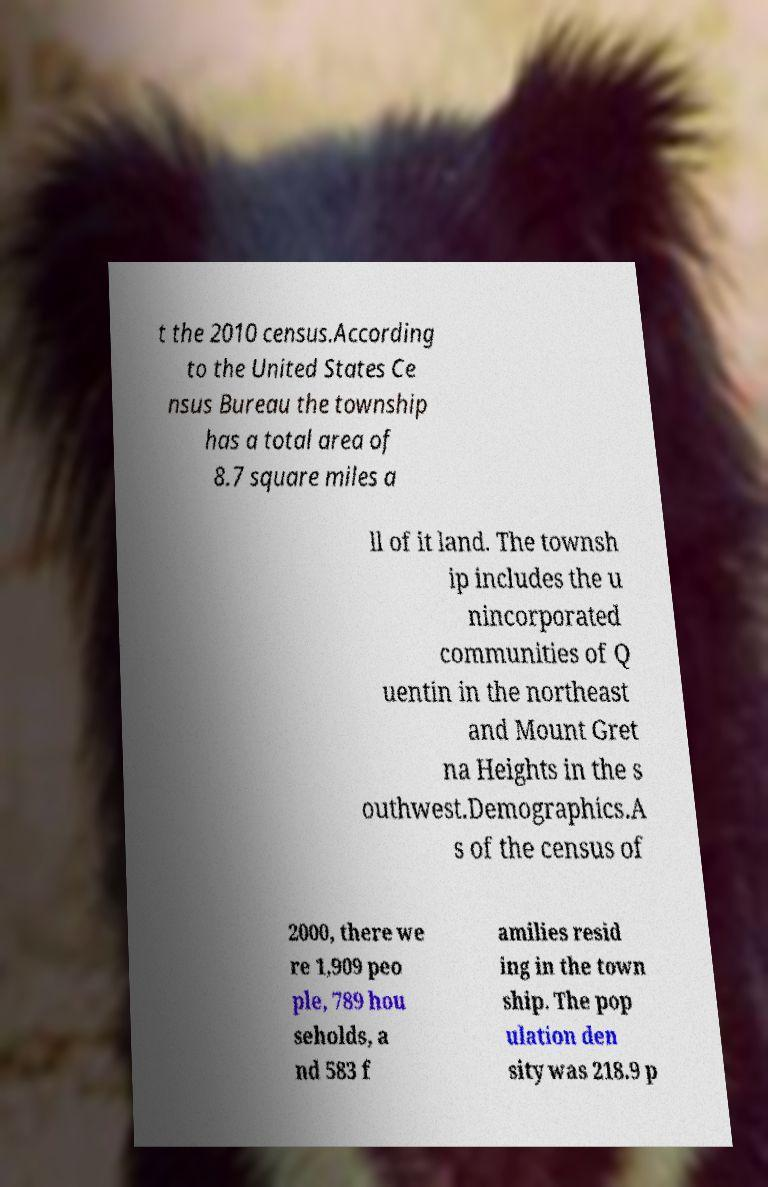Can you accurately transcribe the text from the provided image for me? t the 2010 census.According to the United States Ce nsus Bureau the township has a total area of 8.7 square miles a ll of it land. The townsh ip includes the u nincorporated communities of Q uentin in the northeast and Mount Gret na Heights in the s outhwest.Demographics.A s of the census of 2000, there we re 1,909 peo ple, 789 hou seholds, a nd 583 f amilies resid ing in the town ship. The pop ulation den sity was 218.9 p 